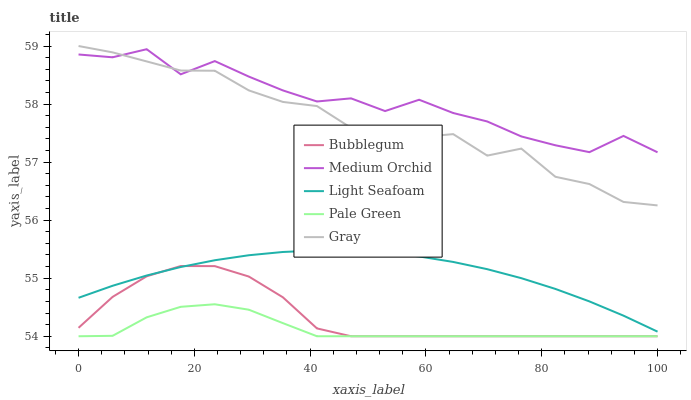Does Pale Green have the minimum area under the curve?
Answer yes or no. Yes. Does Medium Orchid have the maximum area under the curve?
Answer yes or no. Yes. Does Medium Orchid have the minimum area under the curve?
Answer yes or no. No. Does Pale Green have the maximum area under the curve?
Answer yes or no. No. Is Light Seafoam the smoothest?
Answer yes or no. Yes. Is Medium Orchid the roughest?
Answer yes or no. Yes. Is Pale Green the smoothest?
Answer yes or no. No. Is Pale Green the roughest?
Answer yes or no. No. Does Medium Orchid have the lowest value?
Answer yes or no. No. Does Gray have the highest value?
Answer yes or no. Yes. Does Medium Orchid have the highest value?
Answer yes or no. No. Is Bubblegum less than Gray?
Answer yes or no. Yes. Is Medium Orchid greater than Pale Green?
Answer yes or no. Yes. Does Bubblegum intersect Pale Green?
Answer yes or no. Yes. Is Bubblegum less than Pale Green?
Answer yes or no. No. Is Bubblegum greater than Pale Green?
Answer yes or no. No. Does Bubblegum intersect Gray?
Answer yes or no. No. 